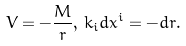Convert formula to latex. <formula><loc_0><loc_0><loc_500><loc_500>V = - \frac { M } { r } , \, k _ { i } d x ^ { i } = - d r .</formula> 